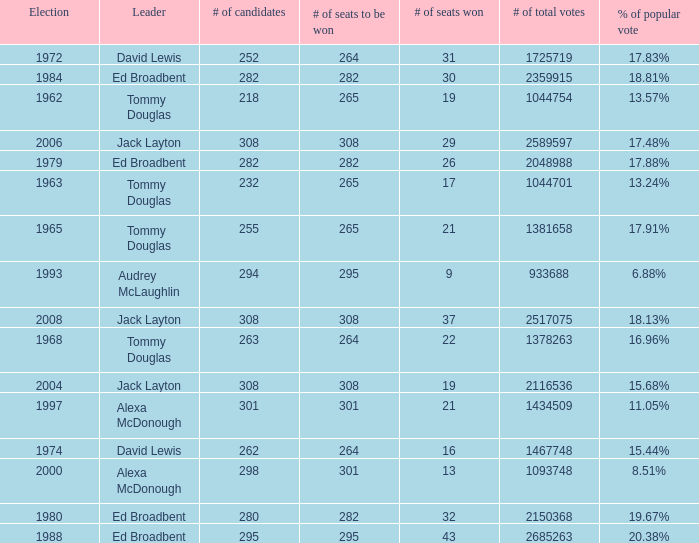Name the number of seats to be won being % of popular vote at 6.88% 295.0. 